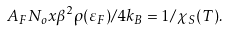<formula> <loc_0><loc_0><loc_500><loc_500>A _ { F } N _ { o } x \beta ^ { 2 } \rho ( \varepsilon _ { F } ) / 4 k _ { B } = 1 / \chi _ { S } ( T ) .</formula> 